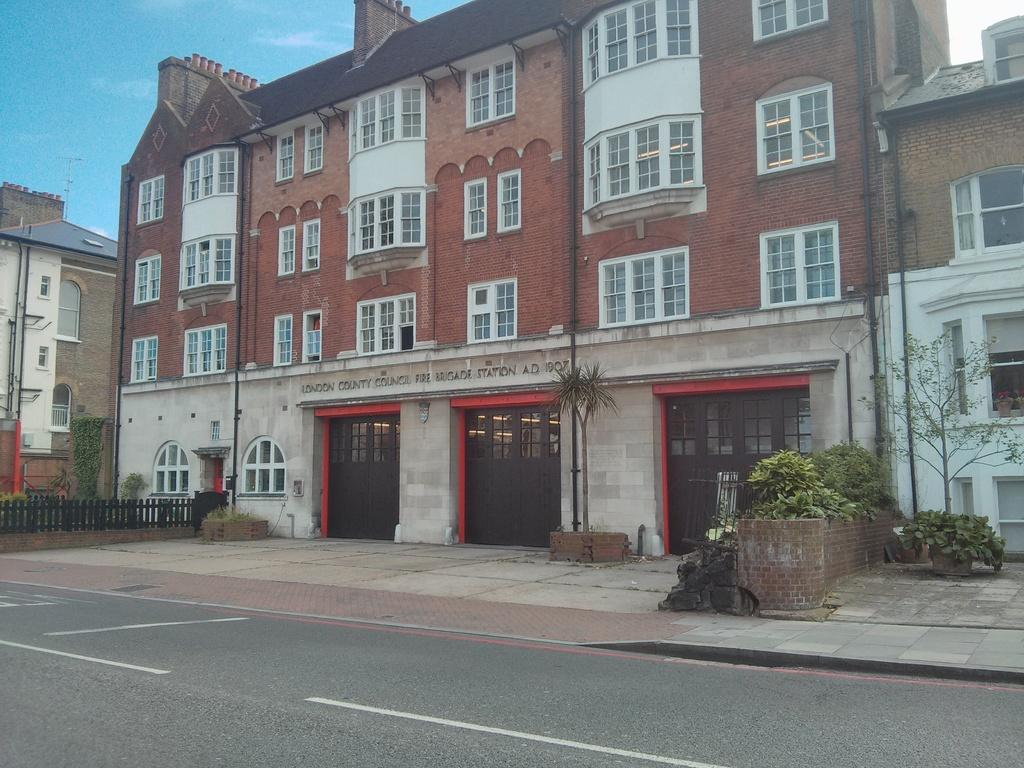What type of living organisms can be seen in the image? Plants can be seen in the image. What color are the plants in the image? The plants are green. What can be seen in the background of the image? Buildings can be seen in the background of the image. What colors are the buildings in the image? The buildings have brown, white, and green colors. What type of barrier is visible in the image? Fencing is visible in the image. What color is the sky in the image? The sky is blue. What type of powder is being used to start the history lesson in the image? There is no powder or history lesson present in the image. 